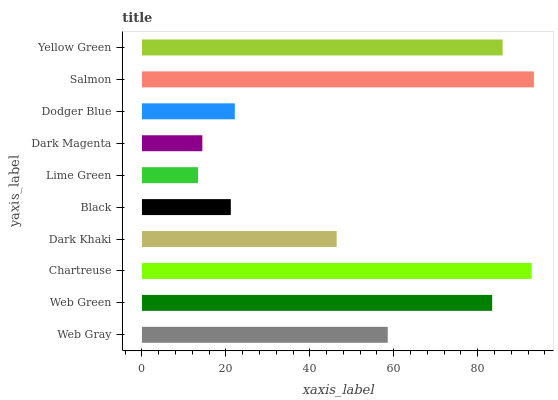Is Lime Green the minimum?
Answer yes or no. Yes. Is Salmon the maximum?
Answer yes or no. Yes. Is Web Green the minimum?
Answer yes or no. No. Is Web Green the maximum?
Answer yes or no. No. Is Web Green greater than Web Gray?
Answer yes or no. Yes. Is Web Gray less than Web Green?
Answer yes or no. Yes. Is Web Gray greater than Web Green?
Answer yes or no. No. Is Web Green less than Web Gray?
Answer yes or no. No. Is Web Gray the high median?
Answer yes or no. Yes. Is Dark Khaki the low median?
Answer yes or no. Yes. Is Web Green the high median?
Answer yes or no. No. Is Salmon the low median?
Answer yes or no. No. 